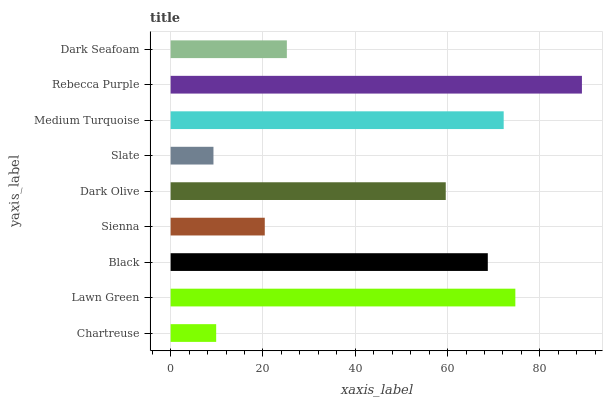Is Slate the minimum?
Answer yes or no. Yes. Is Rebecca Purple the maximum?
Answer yes or no. Yes. Is Lawn Green the minimum?
Answer yes or no. No. Is Lawn Green the maximum?
Answer yes or no. No. Is Lawn Green greater than Chartreuse?
Answer yes or no. Yes. Is Chartreuse less than Lawn Green?
Answer yes or no. Yes. Is Chartreuse greater than Lawn Green?
Answer yes or no. No. Is Lawn Green less than Chartreuse?
Answer yes or no. No. Is Dark Olive the high median?
Answer yes or no. Yes. Is Dark Olive the low median?
Answer yes or no. Yes. Is Rebecca Purple the high median?
Answer yes or no. No. Is Dark Seafoam the low median?
Answer yes or no. No. 